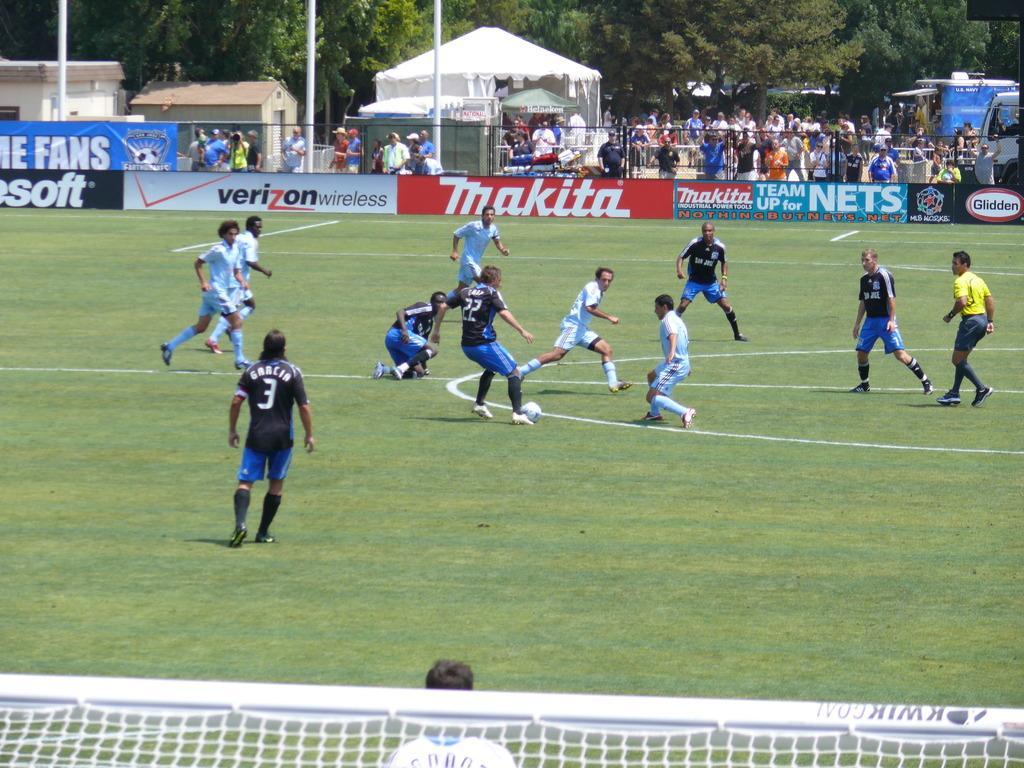Could you give a brief overview of what you see in this image? In the center we can see few players. In bottom we can see net and one person standing. and coming to background we can see tent,group of persons were standing and trees,vehicles,pole etc. 